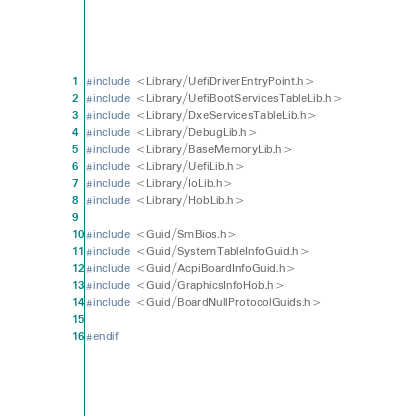<code> <loc_0><loc_0><loc_500><loc_500><_C_>
#include <Library/UefiDriverEntryPoint.h>
#include <Library/UefiBootServicesTableLib.h>
#include <Library/DxeServicesTableLib.h>
#include <Library/DebugLib.h>
#include <Library/BaseMemoryLib.h>
#include <Library/UefiLib.h>
#include <Library/IoLib.h>
#include <Library/HobLib.h>

#include <Guid/SmBios.h>
#include <Guid/SystemTableInfoGuid.h>
#include <Guid/AcpiBoardInfoGuid.h>
#include <Guid/GraphicsInfoHob.h>
#include <Guid/BoardNullProtocolGuids.h>

#endif
</code> 